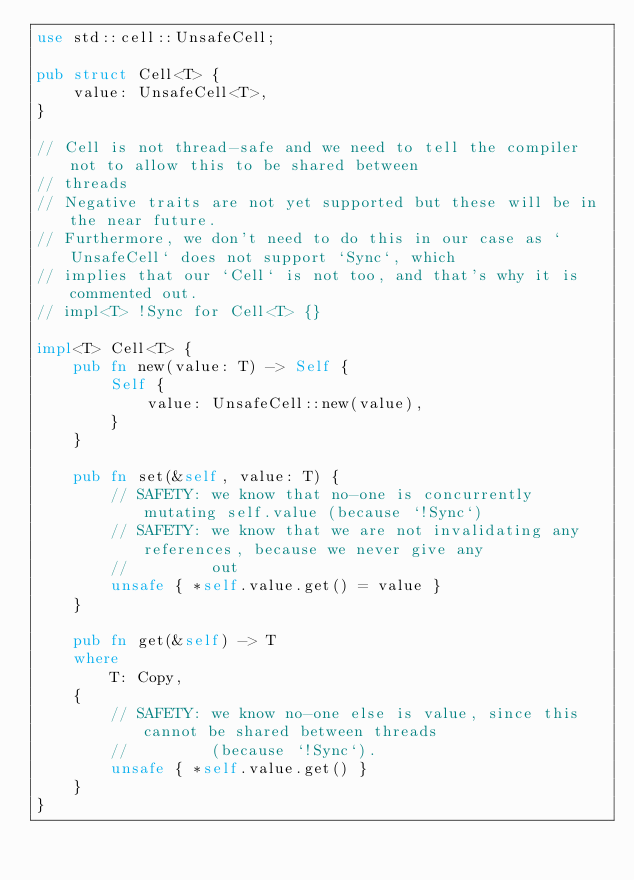Convert code to text. <code><loc_0><loc_0><loc_500><loc_500><_Rust_>use std::cell::UnsafeCell;

pub struct Cell<T> {
    value: UnsafeCell<T>,
}

// Cell is not thread-safe and we need to tell the compiler not to allow this to be shared between
// threads
// Negative traits are not yet supported but these will be in the near future.
// Furthermore, we don't need to do this in our case as `UnsafeCell` does not support `Sync`, which
// implies that our `Cell` is not too, and that's why it is commented out.
// impl<T> !Sync for Cell<T> {}

impl<T> Cell<T> {
    pub fn new(value: T) -> Self {
        Self {
            value: UnsafeCell::new(value),
        }
    }

    pub fn set(&self, value: T) {
        // SAFETY: we know that no-one is concurrently mutating self.value (because `!Sync`)
        // SAFETY: we know that we are not invalidating any references, because we never give any
        //         out
        unsafe { *self.value.get() = value }
    }

    pub fn get(&self) -> T
    where
        T: Copy,
    {
        // SAFETY: we know no-one else is value, since this cannot be shared between threads
        //         (because `!Sync`).
        unsafe { *self.value.get() }
    }
}
</code> 